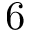Convert formula to latex. <formula><loc_0><loc_0><loc_500><loc_500>6</formula> 